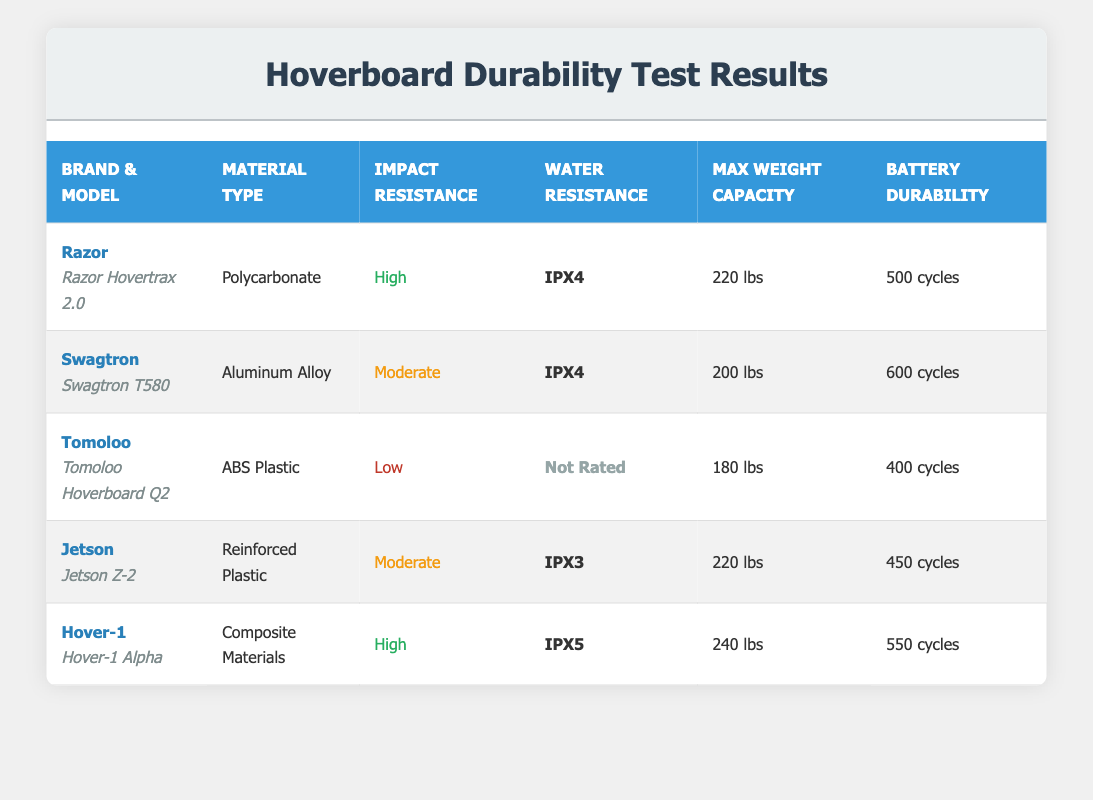What is the max weight capacity of the Hover-1 Alpha? The table shows the max weight capacity listed under the "Max Weight Capacity" column for each hoverboard. For the Hover-1 Alpha, the specific capacity is 240 lbs.
Answer: 240 lbs Which hoverboard has the highest battery durability? By examining the "Battery Durability" column, we see that the Swagtron T580 has the highest value at 600 cycles. I compared each row's battery durability to determine this.
Answer: 600 cycles Is the water resistance rating of the Tomoloo Hoverboard Q2 rated? In the table, the water resistance rating for the Tomoloo Hoverboard Q2 is listed as "Not Rated," meaning it does not have a specific water resistance rating.
Answer: No What material type does the Jetson Z-2 hoverboard use? The material type for the Jetson Z-2 is found directly in the "Material Type" column of the table, which states it is made of Reinforced Plastic.
Answer: Reinforced Plastic Which hoverboard has low impact resistance? To answer this question, I reviewed the "Impact Resistance" column and found that the Tomoloo Hoverboard Q2 is classified as having Low impact resistance.
Answer: Tomoloo Hoverboard Q2 How many hoverboards have a water resistance rating of IPX4? By scanning the "Water Resistance" column, I found that there are two hoverboards, the Razor Hovertrax 2.0 and the Swagtron T580, that have an IPX4 rating.
Answer: 2 What is the difference in battery durability between the Hover-1 Alpha and the Tomoloo Hoverboard Q2? The Hover-1 Alpha provides 550 cycles of battery durability, while the Tomoloo Hoverboard Q2 only provides 400 cycles. The difference is calculated as 550 - 400 = 150 cycles.
Answer: 150 cycles Which hoverboard has the highest impact resistance, and what is its water resistance rating? From the "Impact Resistance" column, both the Razor Hovertrax 2.0 and Hover-1 Alpha have High impact resistance. The water resistance for Hover-1 Alpha is IPX5, while Razor Hovertrax 2.0 has IPX4. Thus, the Hover-1 Alpha has the highest impact resistance and an IPX5 rating.
Answer: Hover-1 Alpha, IPX5 How many hoverboards can support a maximum weight capacity of 220 lbs or more? In the "Max Weight Capacity" column, the Razor Hovertrax 2.0, Jetson Z-2, and Hover-1 Alpha all support 220 lbs or more. Specifically, there are three such models: Razor, Jetson, and Hover-1.
Answer: 3 